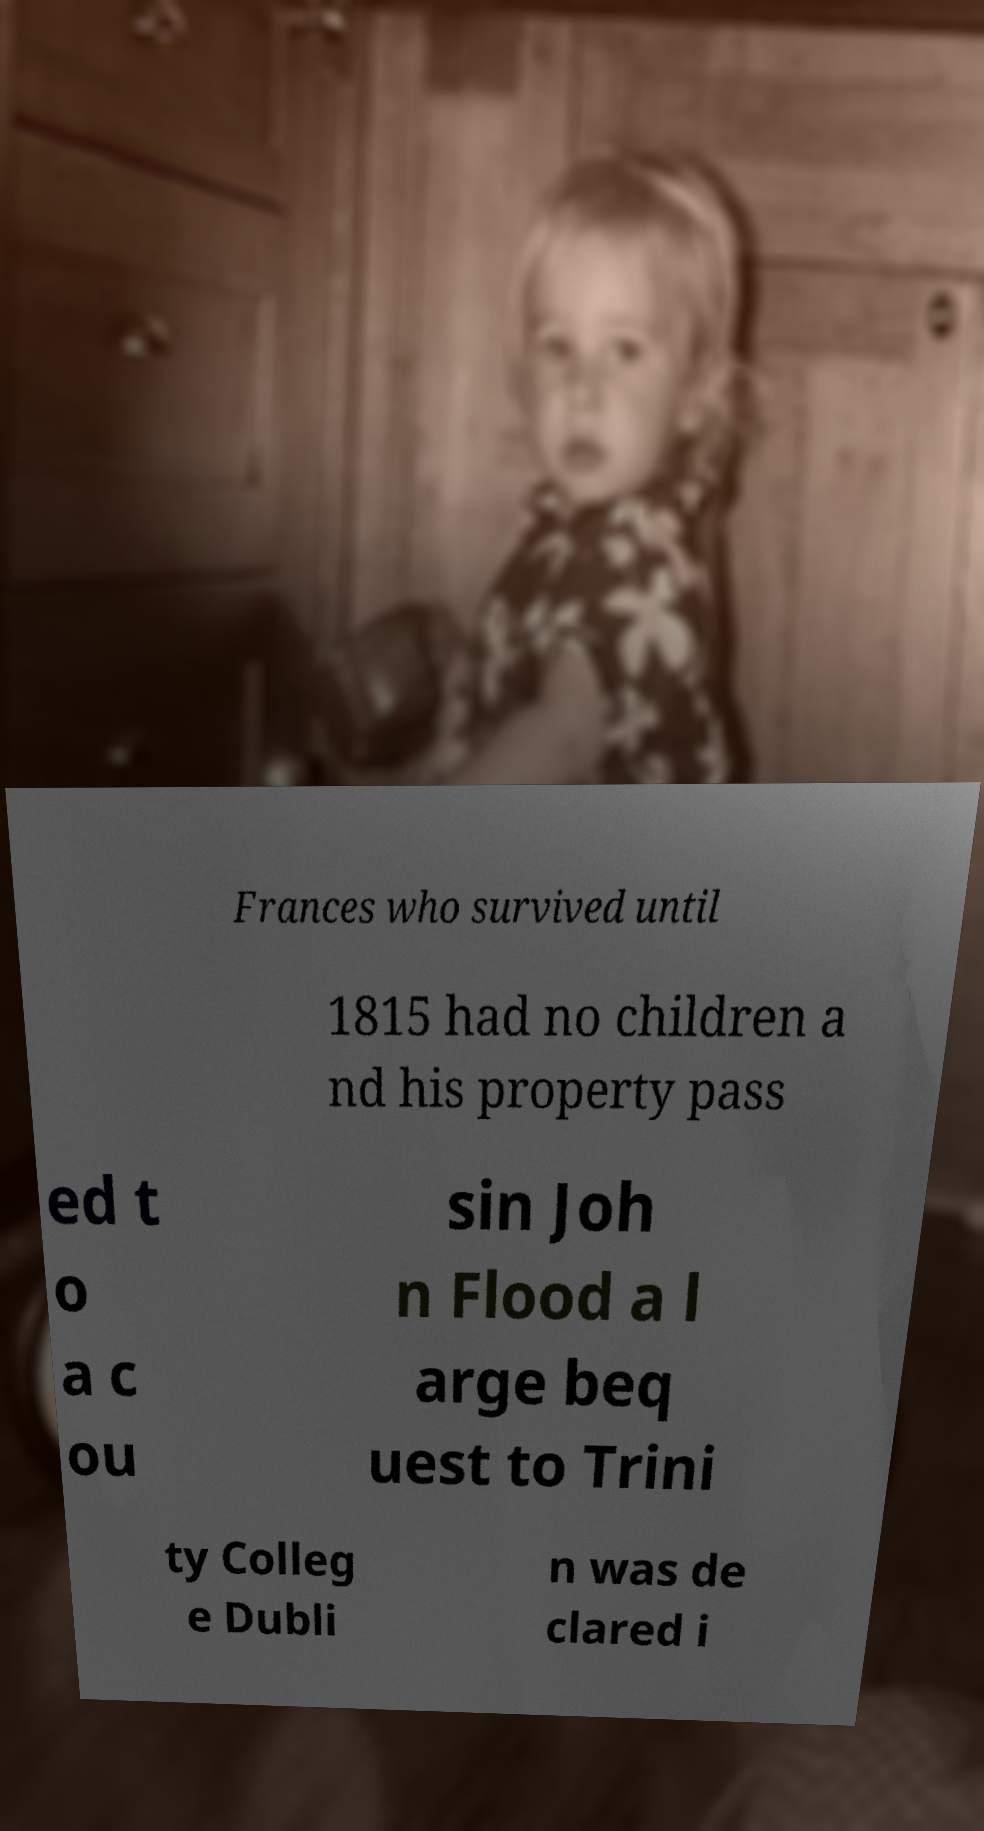Can you read and provide the text displayed in the image?This photo seems to have some interesting text. Can you extract and type it out for me? Frances who survived until 1815 had no children a nd his property pass ed t o a c ou sin Joh n Flood a l arge beq uest to Trini ty Colleg e Dubli n was de clared i 